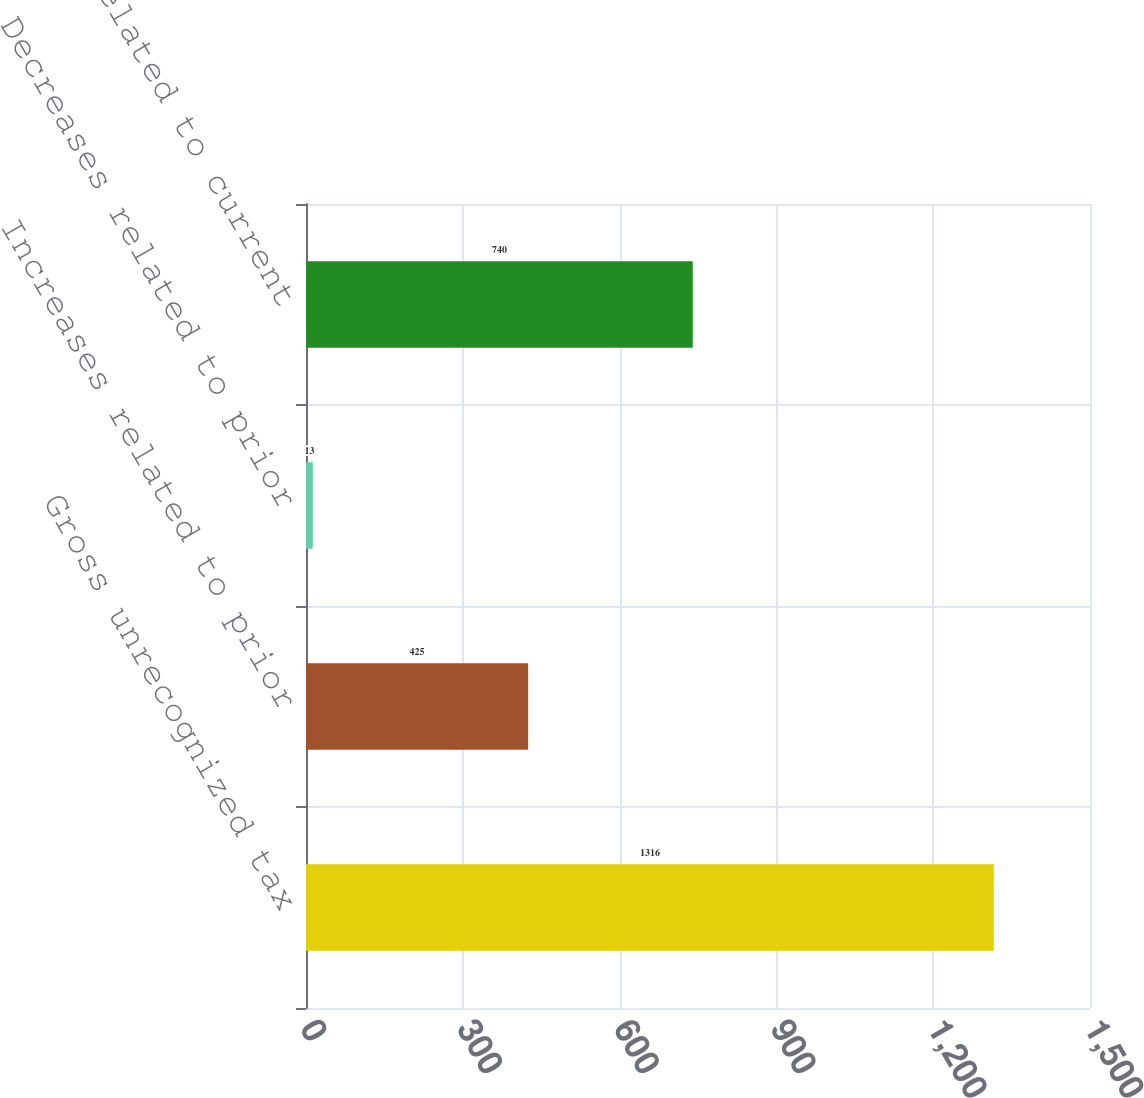<chart> <loc_0><loc_0><loc_500><loc_500><bar_chart><fcel>Gross unrecognized tax<fcel>Increases related to prior<fcel>Decreases related to prior<fcel>Increases related to current<nl><fcel>1316<fcel>425<fcel>13<fcel>740<nl></chart> 